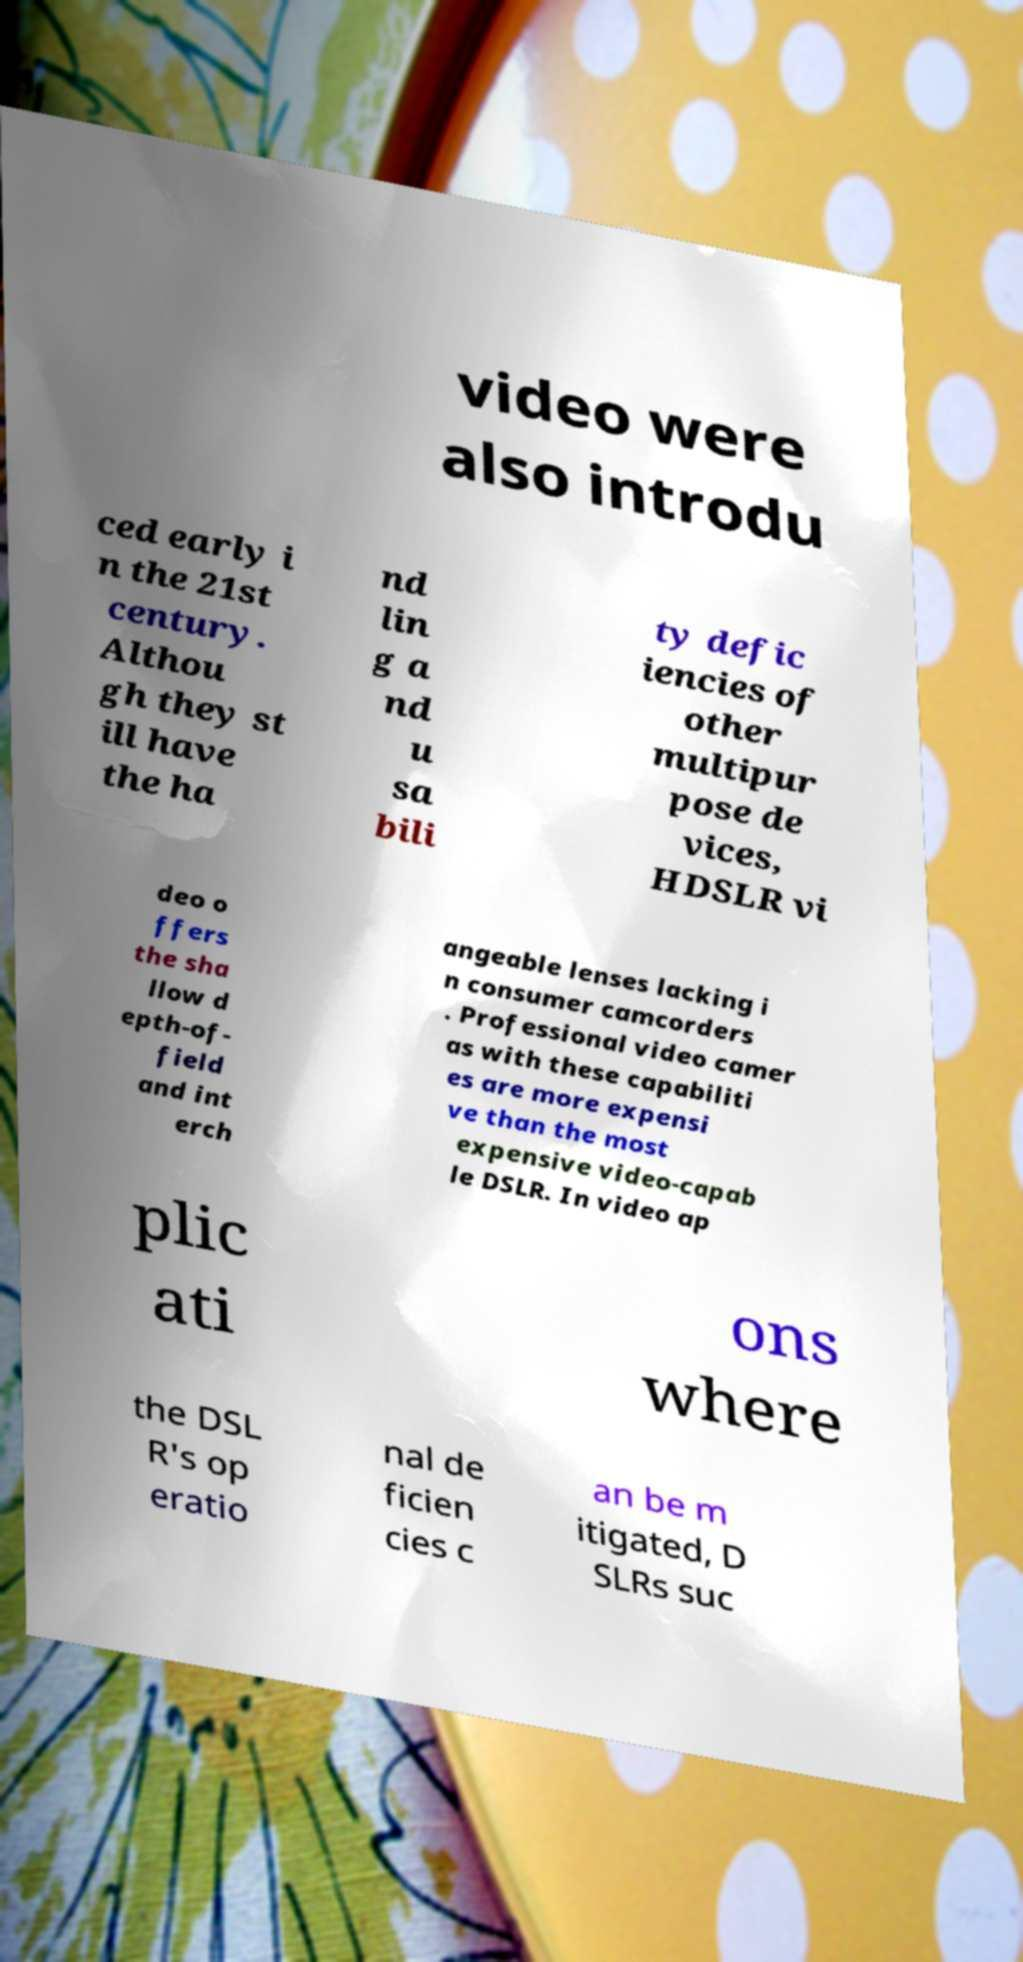I need the written content from this picture converted into text. Can you do that? video were also introdu ced early i n the 21st century. Althou gh they st ill have the ha nd lin g a nd u sa bili ty defic iencies of other multipur pose de vices, HDSLR vi deo o ffers the sha llow d epth-of- field and int erch angeable lenses lacking i n consumer camcorders . Professional video camer as with these capabiliti es are more expensi ve than the most expensive video-capab le DSLR. In video ap plic ati ons where the DSL R's op eratio nal de ficien cies c an be m itigated, D SLRs suc 